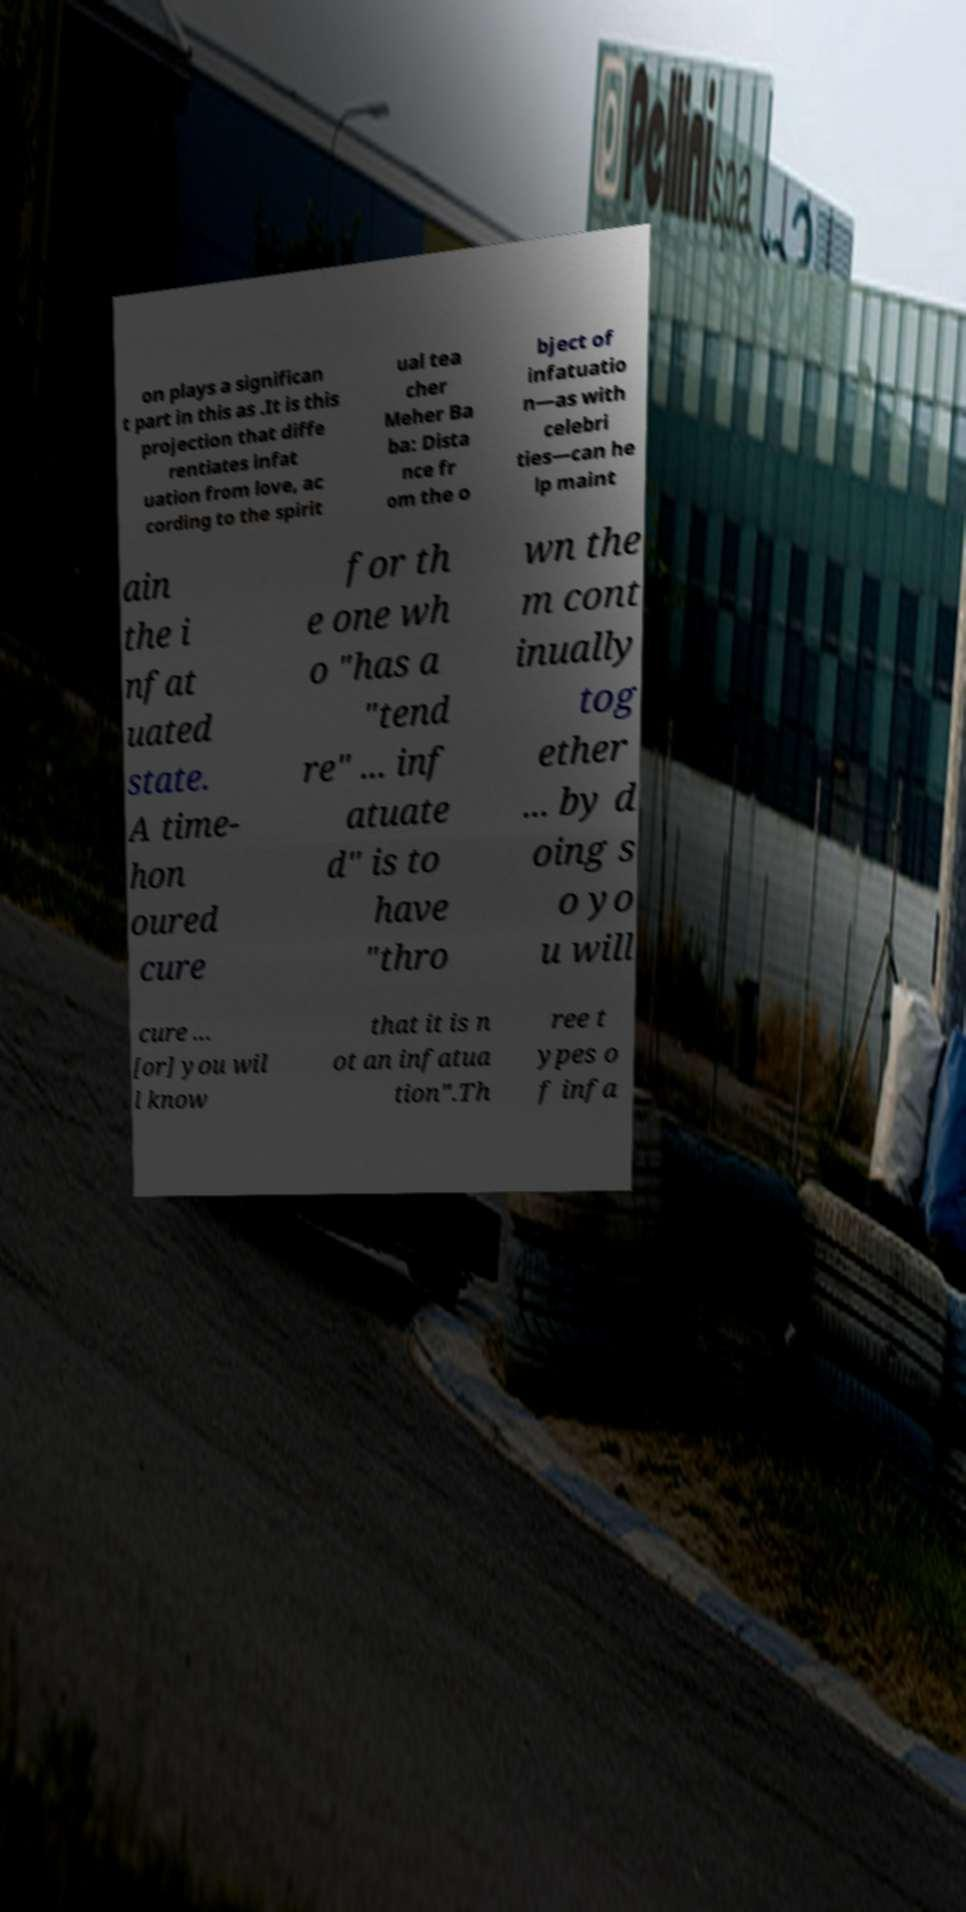Could you assist in decoding the text presented in this image and type it out clearly? on plays a significan t part in this as .It is this projection that diffe rentiates infat uation from love, ac cording to the spirit ual tea cher Meher Ba ba: Dista nce fr om the o bject of infatuatio n—as with celebri ties—can he lp maint ain the i nfat uated state. A time- hon oured cure for th e one wh o "has a "tend re" ... inf atuate d" is to have "thro wn the m cont inually tog ether ... by d oing s o yo u will cure ... [or] you wil l know that it is n ot an infatua tion".Th ree t ypes o f infa 